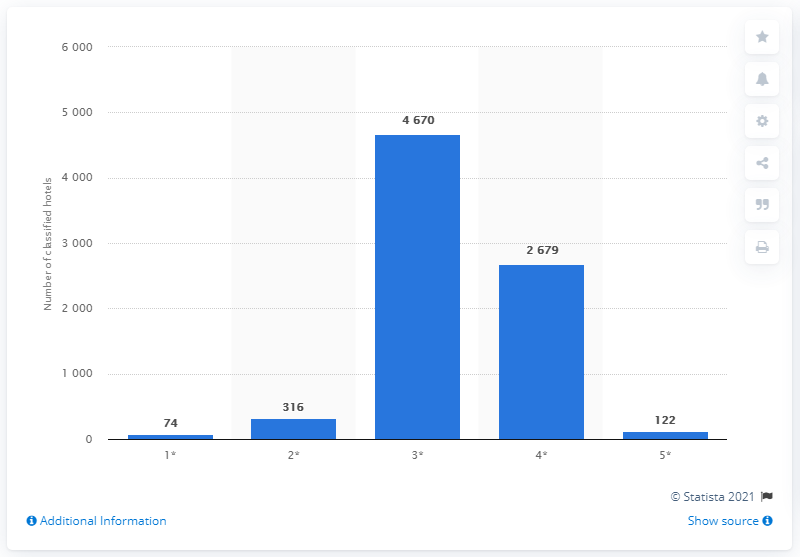Highlight a few significant elements in this photo. As of February 2021, there were 316 2-star hotels in Germany. 